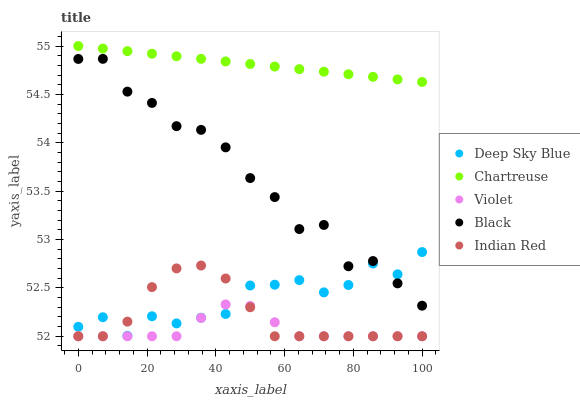Does Violet have the minimum area under the curve?
Answer yes or no. Yes. Does Chartreuse have the maximum area under the curve?
Answer yes or no. Yes. Does Black have the minimum area under the curve?
Answer yes or no. No. Does Black have the maximum area under the curve?
Answer yes or no. No. Is Chartreuse the smoothest?
Answer yes or no. Yes. Is Black the roughest?
Answer yes or no. Yes. Is Indian Red the smoothest?
Answer yes or no. No. Is Indian Red the roughest?
Answer yes or no. No. Does Indian Red have the lowest value?
Answer yes or no. Yes. Does Black have the lowest value?
Answer yes or no. No. Does Chartreuse have the highest value?
Answer yes or no. Yes. Does Black have the highest value?
Answer yes or no. No. Is Deep Sky Blue less than Chartreuse?
Answer yes or no. Yes. Is Chartreuse greater than Violet?
Answer yes or no. Yes. Does Deep Sky Blue intersect Indian Red?
Answer yes or no. Yes. Is Deep Sky Blue less than Indian Red?
Answer yes or no. No. Is Deep Sky Blue greater than Indian Red?
Answer yes or no. No. Does Deep Sky Blue intersect Chartreuse?
Answer yes or no. No. 